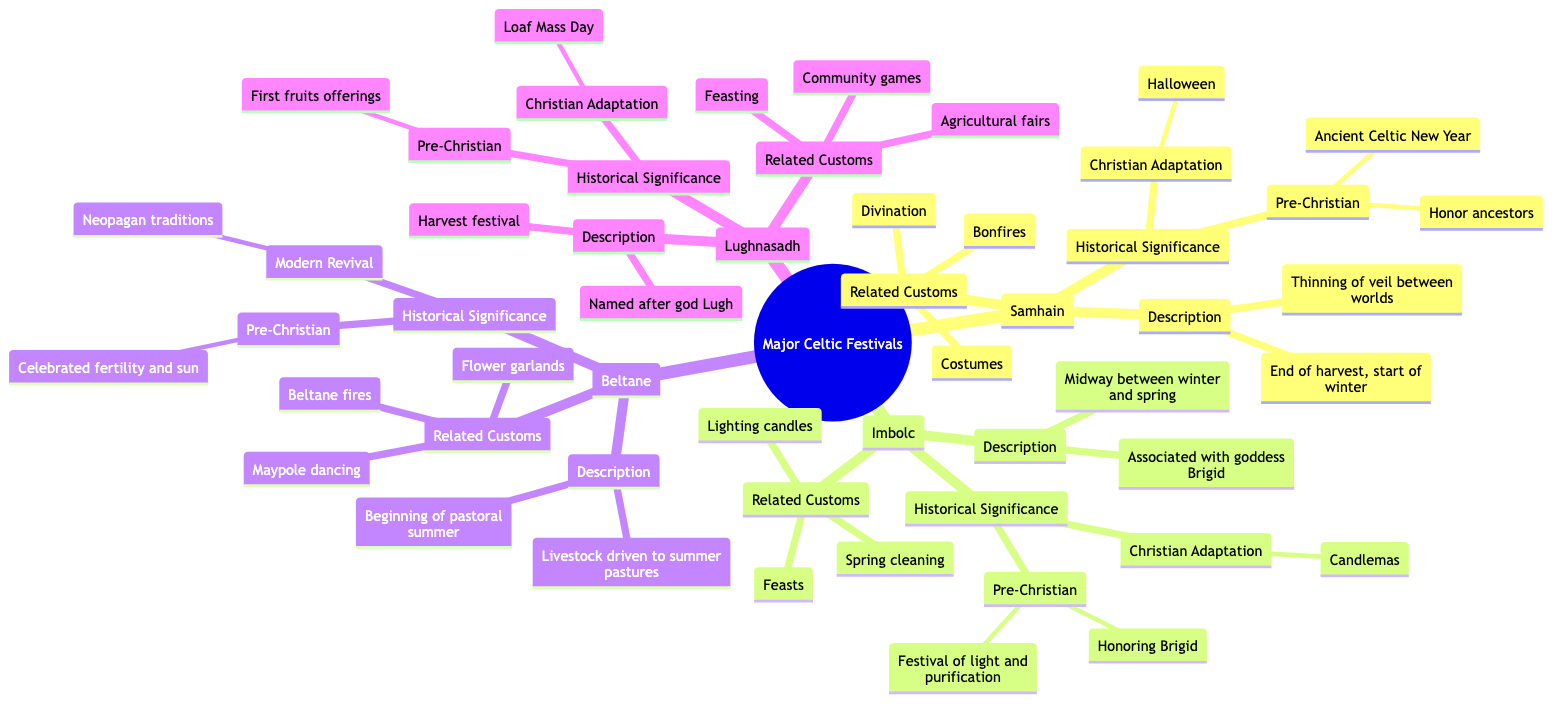What is the significance of Samhain in pre-Christian times? This question pertains to Samhain's historical significance. By reviewing the "Historical Significance" section of Samhain, we find that in pre-Christian times, it was an "Ancient Celtic New Year" and a time to "Honor ancestors."
Answer: Ancient Celtic New Year What related custom is associated with Imbolc? Looking at the "Related Customs" for Imbolc, we can see a list that includes "Lighting candles," "Feasts," and "Spring cleaning." The question asks for any of these.
Answer: Lighting candles What is the primary deity associated with Imbolc? In the description of Imbolc, it states that this festival is "associated with Brigid," who is recognized as the goddess of fertility and healing. Thus, Brigid is the primary deity for this festival.
Answer: Brigid What does Lughnasadh celebrate? The description of Lughnasadh indicates that it is a "harvest festival" that marks "the beginning of the grain harvest season." Therefore, the answer reflects what is celebrated.
Answer: Harvest festival How many related customs are listed for Beltane? Checking the "Related Customs" for Beltane, it lists three customs: "Maypole dancing," "Beltane fires," and "Flower garlands." Therefore, we count these for the answer.
Answer: Three What Christian adaptation is associated with Lughnasadh? In the historical adaptation section for Lughnasadh, it states it relates to "Loaf Mass Day" where the first bread from the harvest was blessed. This is the adaptation mentioned.
Answer: Loaf Mass Day Which festival is marked by bonfires, divination, and costumes? Looking at the "Related Customs" for Samhain, these activities are specifically mentioned. Hence, this inquiry leads directly to Samhain.
Answer: Samhain What does Beltane primarily celebrate in pre-Christian beliefs? Referring back to the historical significance of Beltane, it mentions that this festival "celebrated fertility and the power of the sun," which is the main focus in pre-Christian beliefs.
Answer: Fertility and power of the sun 